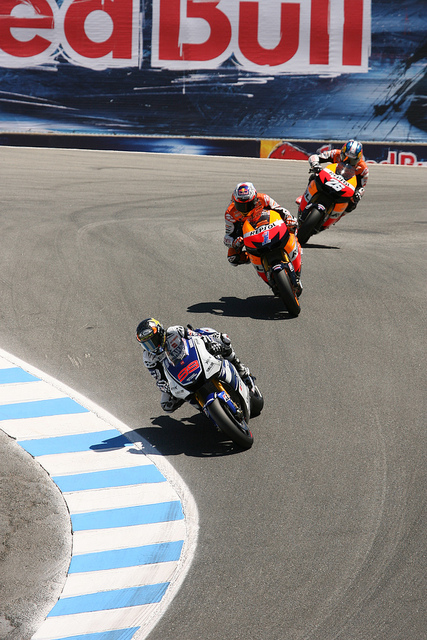<image>What year was this taken? It is ambiguous what year the image was taken. What year was this taken? I don't know what year this was taken. It can be either 2012, 2015, 2016, 2014, 2000 or 1999. 